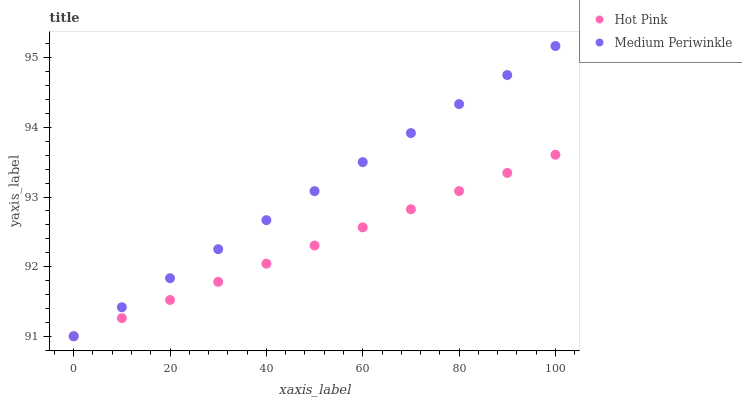Does Hot Pink have the minimum area under the curve?
Answer yes or no. Yes. Does Medium Periwinkle have the maximum area under the curve?
Answer yes or no. Yes. Does Medium Periwinkle have the minimum area under the curve?
Answer yes or no. No. Is Medium Periwinkle the smoothest?
Answer yes or no. Yes. Is Hot Pink the roughest?
Answer yes or no. Yes. Is Medium Periwinkle the roughest?
Answer yes or no. No. Does Hot Pink have the lowest value?
Answer yes or no. Yes. Does Medium Periwinkle have the highest value?
Answer yes or no. Yes. Does Hot Pink intersect Medium Periwinkle?
Answer yes or no. Yes. Is Hot Pink less than Medium Periwinkle?
Answer yes or no. No. Is Hot Pink greater than Medium Periwinkle?
Answer yes or no. No. 